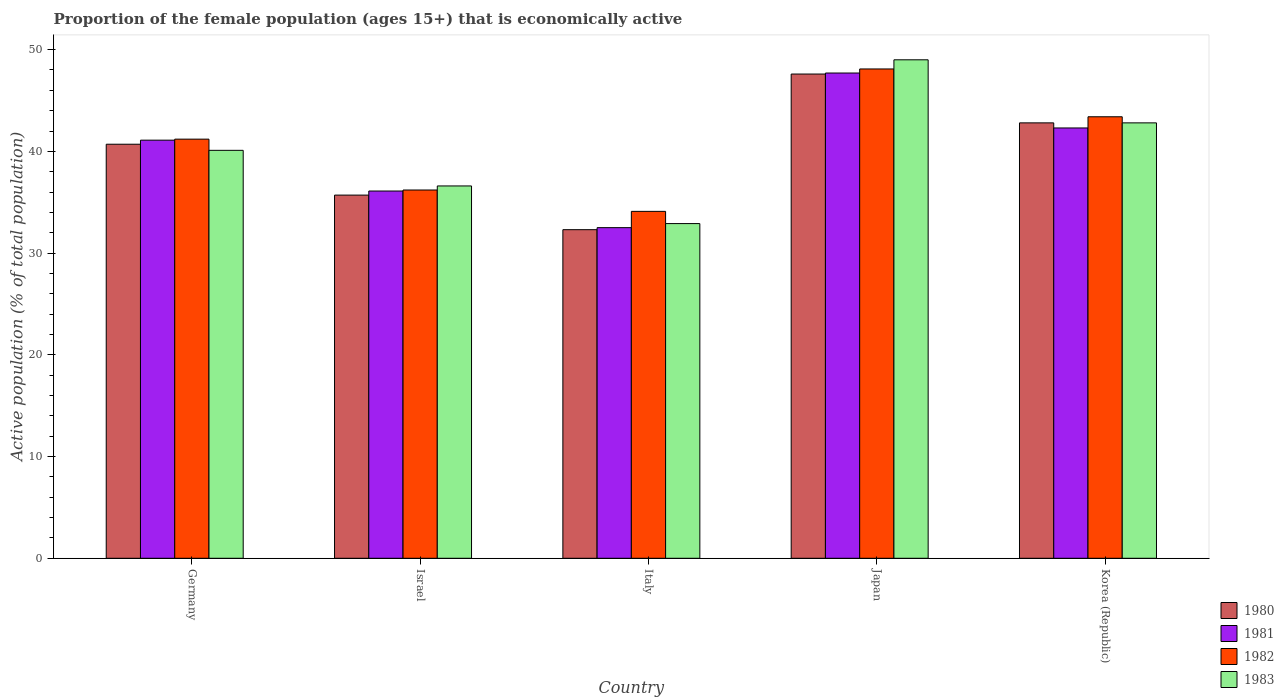Are the number of bars per tick equal to the number of legend labels?
Offer a terse response. Yes. Are the number of bars on each tick of the X-axis equal?
Your response must be concise. Yes. In how many cases, is the number of bars for a given country not equal to the number of legend labels?
Offer a very short reply. 0. What is the proportion of the female population that is economically active in 1980 in Italy?
Offer a terse response. 32.3. Across all countries, what is the maximum proportion of the female population that is economically active in 1982?
Give a very brief answer. 48.1. Across all countries, what is the minimum proportion of the female population that is economically active in 1980?
Your answer should be compact. 32.3. What is the total proportion of the female population that is economically active in 1983 in the graph?
Provide a succinct answer. 201.4. What is the difference between the proportion of the female population that is economically active in 1981 in Israel and that in Italy?
Your response must be concise. 3.6. What is the average proportion of the female population that is economically active in 1983 per country?
Offer a terse response. 40.28. What is the difference between the proportion of the female population that is economically active of/in 1980 and proportion of the female population that is economically active of/in 1982 in Germany?
Give a very brief answer. -0.5. What is the ratio of the proportion of the female population that is economically active in 1980 in Japan to that in Korea (Republic)?
Your response must be concise. 1.11. Is the proportion of the female population that is economically active in 1980 in Israel less than that in Japan?
Your answer should be very brief. Yes. What is the difference between the highest and the second highest proportion of the female population that is economically active in 1980?
Offer a very short reply. -2.1. In how many countries, is the proportion of the female population that is economically active in 1981 greater than the average proportion of the female population that is economically active in 1981 taken over all countries?
Give a very brief answer. 3. Is it the case that in every country, the sum of the proportion of the female population that is economically active in 1982 and proportion of the female population that is economically active in 1980 is greater than the sum of proportion of the female population that is economically active in 1981 and proportion of the female population that is economically active in 1983?
Provide a succinct answer. No. What does the 2nd bar from the left in Italy represents?
Provide a short and direct response. 1981. How many bars are there?
Ensure brevity in your answer.  20. Are all the bars in the graph horizontal?
Provide a short and direct response. No. How many countries are there in the graph?
Your response must be concise. 5. What is the difference between two consecutive major ticks on the Y-axis?
Ensure brevity in your answer.  10. How many legend labels are there?
Offer a very short reply. 4. What is the title of the graph?
Offer a very short reply. Proportion of the female population (ages 15+) that is economically active. Does "2012" appear as one of the legend labels in the graph?
Give a very brief answer. No. What is the label or title of the X-axis?
Ensure brevity in your answer.  Country. What is the label or title of the Y-axis?
Make the answer very short. Active population (% of total population). What is the Active population (% of total population) in 1980 in Germany?
Make the answer very short. 40.7. What is the Active population (% of total population) of 1981 in Germany?
Provide a succinct answer. 41.1. What is the Active population (% of total population) in 1982 in Germany?
Your answer should be compact. 41.2. What is the Active population (% of total population) in 1983 in Germany?
Your answer should be very brief. 40.1. What is the Active population (% of total population) of 1980 in Israel?
Keep it short and to the point. 35.7. What is the Active population (% of total population) of 1981 in Israel?
Your answer should be very brief. 36.1. What is the Active population (% of total population) of 1982 in Israel?
Ensure brevity in your answer.  36.2. What is the Active population (% of total population) in 1983 in Israel?
Your answer should be compact. 36.6. What is the Active population (% of total population) in 1980 in Italy?
Offer a terse response. 32.3. What is the Active population (% of total population) in 1981 in Italy?
Keep it short and to the point. 32.5. What is the Active population (% of total population) in 1982 in Italy?
Offer a terse response. 34.1. What is the Active population (% of total population) in 1983 in Italy?
Offer a very short reply. 32.9. What is the Active population (% of total population) in 1980 in Japan?
Give a very brief answer. 47.6. What is the Active population (% of total population) in 1981 in Japan?
Your response must be concise. 47.7. What is the Active population (% of total population) in 1982 in Japan?
Offer a terse response. 48.1. What is the Active population (% of total population) of 1983 in Japan?
Your answer should be compact. 49. What is the Active population (% of total population) of 1980 in Korea (Republic)?
Offer a very short reply. 42.8. What is the Active population (% of total population) in 1981 in Korea (Republic)?
Offer a terse response. 42.3. What is the Active population (% of total population) of 1982 in Korea (Republic)?
Make the answer very short. 43.4. What is the Active population (% of total population) of 1983 in Korea (Republic)?
Provide a short and direct response. 42.8. Across all countries, what is the maximum Active population (% of total population) in 1980?
Your response must be concise. 47.6. Across all countries, what is the maximum Active population (% of total population) of 1981?
Provide a short and direct response. 47.7. Across all countries, what is the maximum Active population (% of total population) in 1982?
Offer a very short reply. 48.1. Across all countries, what is the maximum Active population (% of total population) of 1983?
Your answer should be very brief. 49. Across all countries, what is the minimum Active population (% of total population) in 1980?
Your answer should be compact. 32.3. Across all countries, what is the minimum Active population (% of total population) in 1981?
Offer a very short reply. 32.5. Across all countries, what is the minimum Active population (% of total population) of 1982?
Keep it short and to the point. 34.1. Across all countries, what is the minimum Active population (% of total population) of 1983?
Your answer should be compact. 32.9. What is the total Active population (% of total population) of 1980 in the graph?
Offer a terse response. 199.1. What is the total Active population (% of total population) in 1981 in the graph?
Your response must be concise. 199.7. What is the total Active population (% of total population) of 1982 in the graph?
Offer a terse response. 203. What is the total Active population (% of total population) of 1983 in the graph?
Provide a short and direct response. 201.4. What is the difference between the Active population (% of total population) of 1982 in Germany and that in Israel?
Your answer should be very brief. 5. What is the difference between the Active population (% of total population) in 1983 in Germany and that in Israel?
Your answer should be compact. 3.5. What is the difference between the Active population (% of total population) of 1982 in Germany and that in Italy?
Your answer should be very brief. 7.1. What is the difference between the Active population (% of total population) in 1983 in Germany and that in Italy?
Your response must be concise. 7.2. What is the difference between the Active population (% of total population) of 1980 in Germany and that in Japan?
Your answer should be very brief. -6.9. What is the difference between the Active population (% of total population) in 1981 in Germany and that in Japan?
Provide a short and direct response. -6.6. What is the difference between the Active population (% of total population) of 1980 in Germany and that in Korea (Republic)?
Your response must be concise. -2.1. What is the difference between the Active population (% of total population) of 1982 in Germany and that in Korea (Republic)?
Your response must be concise. -2.2. What is the difference between the Active population (% of total population) of 1983 in Germany and that in Korea (Republic)?
Your answer should be compact. -2.7. What is the difference between the Active population (% of total population) in 1980 in Israel and that in Italy?
Give a very brief answer. 3.4. What is the difference between the Active population (% of total population) in 1982 in Israel and that in Italy?
Your answer should be very brief. 2.1. What is the difference between the Active population (% of total population) in 1983 in Israel and that in Italy?
Make the answer very short. 3.7. What is the difference between the Active population (% of total population) in 1980 in Israel and that in Japan?
Keep it short and to the point. -11.9. What is the difference between the Active population (% of total population) in 1982 in Israel and that in Japan?
Your response must be concise. -11.9. What is the difference between the Active population (% of total population) in 1983 in Israel and that in Japan?
Offer a terse response. -12.4. What is the difference between the Active population (% of total population) in 1981 in Israel and that in Korea (Republic)?
Your response must be concise. -6.2. What is the difference between the Active population (% of total population) of 1982 in Israel and that in Korea (Republic)?
Make the answer very short. -7.2. What is the difference between the Active population (% of total population) of 1980 in Italy and that in Japan?
Provide a succinct answer. -15.3. What is the difference between the Active population (% of total population) of 1981 in Italy and that in Japan?
Your response must be concise. -15.2. What is the difference between the Active population (% of total population) of 1983 in Italy and that in Japan?
Your response must be concise. -16.1. What is the difference between the Active population (% of total population) in 1981 in Italy and that in Korea (Republic)?
Offer a terse response. -9.8. What is the difference between the Active population (% of total population) of 1982 in Italy and that in Korea (Republic)?
Ensure brevity in your answer.  -9.3. What is the difference between the Active population (% of total population) of 1981 in Japan and that in Korea (Republic)?
Your answer should be very brief. 5.4. What is the difference between the Active population (% of total population) of 1982 in Japan and that in Korea (Republic)?
Make the answer very short. 4.7. What is the difference between the Active population (% of total population) in 1980 in Germany and the Active population (% of total population) in 1981 in Israel?
Your answer should be compact. 4.6. What is the difference between the Active population (% of total population) of 1980 in Germany and the Active population (% of total population) of 1982 in Israel?
Ensure brevity in your answer.  4.5. What is the difference between the Active population (% of total population) in 1982 in Germany and the Active population (% of total population) in 1983 in Israel?
Provide a short and direct response. 4.6. What is the difference between the Active population (% of total population) of 1980 in Germany and the Active population (% of total population) of 1982 in Italy?
Ensure brevity in your answer.  6.6. What is the difference between the Active population (% of total population) in 1980 in Germany and the Active population (% of total population) in 1983 in Italy?
Offer a terse response. 7.8. What is the difference between the Active population (% of total population) in 1981 in Germany and the Active population (% of total population) in 1983 in Italy?
Provide a succinct answer. 8.2. What is the difference between the Active population (% of total population) in 1980 in Germany and the Active population (% of total population) in 1981 in Japan?
Offer a very short reply. -7. What is the difference between the Active population (% of total population) in 1980 in Germany and the Active population (% of total population) in 1982 in Japan?
Make the answer very short. -7.4. What is the difference between the Active population (% of total population) of 1980 in Germany and the Active population (% of total population) of 1983 in Japan?
Offer a very short reply. -8.3. What is the difference between the Active population (% of total population) in 1982 in Germany and the Active population (% of total population) in 1983 in Japan?
Your response must be concise. -7.8. What is the difference between the Active population (% of total population) of 1980 in Germany and the Active population (% of total population) of 1981 in Korea (Republic)?
Provide a short and direct response. -1.6. What is the difference between the Active population (% of total population) in 1980 in Germany and the Active population (% of total population) in 1982 in Korea (Republic)?
Provide a short and direct response. -2.7. What is the difference between the Active population (% of total population) of 1981 in Germany and the Active population (% of total population) of 1982 in Korea (Republic)?
Keep it short and to the point. -2.3. What is the difference between the Active population (% of total population) of 1981 in Germany and the Active population (% of total population) of 1983 in Korea (Republic)?
Give a very brief answer. -1.7. What is the difference between the Active population (% of total population) in 1980 in Israel and the Active population (% of total population) in 1981 in Italy?
Your answer should be compact. 3.2. What is the difference between the Active population (% of total population) of 1980 in Israel and the Active population (% of total population) of 1982 in Italy?
Your answer should be very brief. 1.6. What is the difference between the Active population (% of total population) in 1981 in Israel and the Active population (% of total population) in 1983 in Italy?
Your answer should be compact. 3.2. What is the difference between the Active population (% of total population) in 1982 in Israel and the Active population (% of total population) in 1983 in Italy?
Offer a terse response. 3.3. What is the difference between the Active population (% of total population) in 1981 in Israel and the Active population (% of total population) in 1982 in Japan?
Offer a terse response. -12. What is the difference between the Active population (% of total population) of 1982 in Israel and the Active population (% of total population) of 1983 in Japan?
Offer a terse response. -12.8. What is the difference between the Active population (% of total population) of 1980 in Israel and the Active population (% of total population) of 1981 in Korea (Republic)?
Your answer should be very brief. -6.6. What is the difference between the Active population (% of total population) in 1980 in Israel and the Active population (% of total population) in 1983 in Korea (Republic)?
Make the answer very short. -7.1. What is the difference between the Active population (% of total population) in 1981 in Israel and the Active population (% of total population) in 1982 in Korea (Republic)?
Keep it short and to the point. -7.3. What is the difference between the Active population (% of total population) in 1981 in Israel and the Active population (% of total population) in 1983 in Korea (Republic)?
Offer a very short reply. -6.7. What is the difference between the Active population (% of total population) in 1982 in Israel and the Active population (% of total population) in 1983 in Korea (Republic)?
Keep it short and to the point. -6.6. What is the difference between the Active population (% of total population) in 1980 in Italy and the Active population (% of total population) in 1981 in Japan?
Provide a succinct answer. -15.4. What is the difference between the Active population (% of total population) in 1980 in Italy and the Active population (% of total population) in 1982 in Japan?
Offer a very short reply. -15.8. What is the difference between the Active population (% of total population) in 1980 in Italy and the Active population (% of total population) in 1983 in Japan?
Offer a terse response. -16.7. What is the difference between the Active population (% of total population) of 1981 in Italy and the Active population (% of total population) of 1982 in Japan?
Ensure brevity in your answer.  -15.6. What is the difference between the Active population (% of total population) of 1981 in Italy and the Active population (% of total population) of 1983 in Japan?
Offer a terse response. -16.5. What is the difference between the Active population (% of total population) of 1982 in Italy and the Active population (% of total population) of 1983 in Japan?
Provide a short and direct response. -14.9. What is the difference between the Active population (% of total population) in 1980 in Italy and the Active population (% of total population) in 1981 in Korea (Republic)?
Offer a terse response. -10. What is the difference between the Active population (% of total population) of 1980 in Italy and the Active population (% of total population) of 1982 in Korea (Republic)?
Make the answer very short. -11.1. What is the difference between the Active population (% of total population) of 1981 in Italy and the Active population (% of total population) of 1983 in Korea (Republic)?
Offer a very short reply. -10.3. What is the difference between the Active population (% of total population) in 1980 in Japan and the Active population (% of total population) in 1981 in Korea (Republic)?
Give a very brief answer. 5.3. What is the difference between the Active population (% of total population) of 1980 in Japan and the Active population (% of total population) of 1982 in Korea (Republic)?
Provide a short and direct response. 4.2. What is the difference between the Active population (% of total population) in 1981 in Japan and the Active population (% of total population) in 1982 in Korea (Republic)?
Keep it short and to the point. 4.3. What is the average Active population (% of total population) of 1980 per country?
Your response must be concise. 39.82. What is the average Active population (% of total population) in 1981 per country?
Your answer should be compact. 39.94. What is the average Active population (% of total population) of 1982 per country?
Your response must be concise. 40.6. What is the average Active population (% of total population) of 1983 per country?
Offer a very short reply. 40.28. What is the difference between the Active population (% of total population) in 1980 and Active population (% of total population) in 1981 in Germany?
Provide a short and direct response. -0.4. What is the difference between the Active population (% of total population) of 1980 and Active population (% of total population) of 1982 in Germany?
Offer a very short reply. -0.5. What is the difference between the Active population (% of total population) of 1980 and Active population (% of total population) of 1983 in Germany?
Provide a short and direct response. 0.6. What is the difference between the Active population (% of total population) in 1981 and Active population (% of total population) in 1982 in Germany?
Keep it short and to the point. -0.1. What is the difference between the Active population (% of total population) of 1982 and Active population (% of total population) of 1983 in Germany?
Provide a succinct answer. 1.1. What is the difference between the Active population (% of total population) of 1980 and Active population (% of total population) of 1982 in Israel?
Provide a short and direct response. -0.5. What is the difference between the Active population (% of total population) in 1980 and Active population (% of total population) in 1983 in Israel?
Your answer should be compact. -0.9. What is the difference between the Active population (% of total population) of 1981 and Active population (% of total population) of 1983 in Israel?
Make the answer very short. -0.5. What is the difference between the Active population (% of total population) of 1982 and Active population (% of total population) of 1983 in Israel?
Keep it short and to the point. -0.4. What is the difference between the Active population (% of total population) of 1980 and Active population (% of total population) of 1981 in Italy?
Give a very brief answer. -0.2. What is the difference between the Active population (% of total population) of 1980 and Active population (% of total population) of 1982 in Italy?
Make the answer very short. -1.8. What is the difference between the Active population (% of total population) of 1980 and Active population (% of total population) of 1983 in Italy?
Your answer should be very brief. -0.6. What is the difference between the Active population (% of total population) in 1980 and Active population (% of total population) in 1981 in Japan?
Provide a short and direct response. -0.1. What is the difference between the Active population (% of total population) in 1980 and Active population (% of total population) in 1983 in Japan?
Provide a succinct answer. -1.4. What is the difference between the Active population (% of total population) of 1980 and Active population (% of total population) of 1982 in Korea (Republic)?
Provide a succinct answer. -0.6. What is the difference between the Active population (% of total population) in 1981 and Active population (% of total population) in 1982 in Korea (Republic)?
Your answer should be compact. -1.1. What is the difference between the Active population (% of total population) of 1981 and Active population (% of total population) of 1983 in Korea (Republic)?
Offer a very short reply. -0.5. What is the difference between the Active population (% of total population) of 1982 and Active population (% of total population) of 1983 in Korea (Republic)?
Your response must be concise. 0.6. What is the ratio of the Active population (% of total population) of 1980 in Germany to that in Israel?
Give a very brief answer. 1.14. What is the ratio of the Active population (% of total population) in 1981 in Germany to that in Israel?
Keep it short and to the point. 1.14. What is the ratio of the Active population (% of total population) of 1982 in Germany to that in Israel?
Your response must be concise. 1.14. What is the ratio of the Active population (% of total population) in 1983 in Germany to that in Israel?
Make the answer very short. 1.1. What is the ratio of the Active population (% of total population) in 1980 in Germany to that in Italy?
Keep it short and to the point. 1.26. What is the ratio of the Active population (% of total population) of 1981 in Germany to that in Italy?
Your answer should be compact. 1.26. What is the ratio of the Active population (% of total population) of 1982 in Germany to that in Italy?
Offer a terse response. 1.21. What is the ratio of the Active population (% of total population) of 1983 in Germany to that in Italy?
Make the answer very short. 1.22. What is the ratio of the Active population (% of total population) in 1980 in Germany to that in Japan?
Offer a terse response. 0.85. What is the ratio of the Active population (% of total population) in 1981 in Germany to that in Japan?
Give a very brief answer. 0.86. What is the ratio of the Active population (% of total population) in 1982 in Germany to that in Japan?
Ensure brevity in your answer.  0.86. What is the ratio of the Active population (% of total population) of 1983 in Germany to that in Japan?
Ensure brevity in your answer.  0.82. What is the ratio of the Active population (% of total population) of 1980 in Germany to that in Korea (Republic)?
Keep it short and to the point. 0.95. What is the ratio of the Active population (% of total population) of 1981 in Germany to that in Korea (Republic)?
Offer a terse response. 0.97. What is the ratio of the Active population (% of total population) of 1982 in Germany to that in Korea (Republic)?
Ensure brevity in your answer.  0.95. What is the ratio of the Active population (% of total population) of 1983 in Germany to that in Korea (Republic)?
Your answer should be compact. 0.94. What is the ratio of the Active population (% of total population) of 1980 in Israel to that in Italy?
Keep it short and to the point. 1.11. What is the ratio of the Active population (% of total population) of 1981 in Israel to that in Italy?
Your response must be concise. 1.11. What is the ratio of the Active population (% of total population) in 1982 in Israel to that in Italy?
Ensure brevity in your answer.  1.06. What is the ratio of the Active population (% of total population) in 1983 in Israel to that in Italy?
Offer a very short reply. 1.11. What is the ratio of the Active population (% of total population) of 1981 in Israel to that in Japan?
Provide a short and direct response. 0.76. What is the ratio of the Active population (% of total population) of 1982 in Israel to that in Japan?
Your answer should be compact. 0.75. What is the ratio of the Active population (% of total population) of 1983 in Israel to that in Japan?
Offer a terse response. 0.75. What is the ratio of the Active population (% of total population) in 1980 in Israel to that in Korea (Republic)?
Ensure brevity in your answer.  0.83. What is the ratio of the Active population (% of total population) in 1981 in Israel to that in Korea (Republic)?
Keep it short and to the point. 0.85. What is the ratio of the Active population (% of total population) of 1982 in Israel to that in Korea (Republic)?
Offer a very short reply. 0.83. What is the ratio of the Active population (% of total population) in 1983 in Israel to that in Korea (Republic)?
Make the answer very short. 0.86. What is the ratio of the Active population (% of total population) of 1980 in Italy to that in Japan?
Ensure brevity in your answer.  0.68. What is the ratio of the Active population (% of total population) in 1981 in Italy to that in Japan?
Your answer should be very brief. 0.68. What is the ratio of the Active population (% of total population) of 1982 in Italy to that in Japan?
Your answer should be compact. 0.71. What is the ratio of the Active population (% of total population) of 1983 in Italy to that in Japan?
Your response must be concise. 0.67. What is the ratio of the Active population (% of total population) in 1980 in Italy to that in Korea (Republic)?
Your answer should be very brief. 0.75. What is the ratio of the Active population (% of total population) in 1981 in Italy to that in Korea (Republic)?
Give a very brief answer. 0.77. What is the ratio of the Active population (% of total population) of 1982 in Italy to that in Korea (Republic)?
Provide a succinct answer. 0.79. What is the ratio of the Active population (% of total population) of 1983 in Italy to that in Korea (Republic)?
Your response must be concise. 0.77. What is the ratio of the Active population (% of total population) of 1980 in Japan to that in Korea (Republic)?
Provide a succinct answer. 1.11. What is the ratio of the Active population (% of total population) in 1981 in Japan to that in Korea (Republic)?
Ensure brevity in your answer.  1.13. What is the ratio of the Active population (% of total population) in 1982 in Japan to that in Korea (Republic)?
Your response must be concise. 1.11. What is the ratio of the Active population (% of total population) in 1983 in Japan to that in Korea (Republic)?
Your response must be concise. 1.14. What is the difference between the highest and the second highest Active population (% of total population) of 1980?
Your answer should be very brief. 4.8. What is the difference between the highest and the second highest Active population (% of total population) of 1981?
Give a very brief answer. 5.4. What is the difference between the highest and the second highest Active population (% of total population) in 1983?
Give a very brief answer. 6.2. What is the difference between the highest and the lowest Active population (% of total population) in 1980?
Offer a terse response. 15.3. 